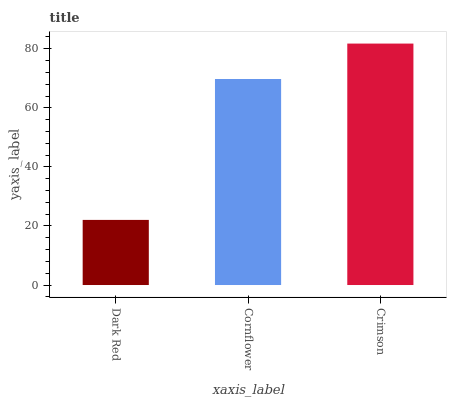Is Dark Red the minimum?
Answer yes or no. Yes. Is Crimson the maximum?
Answer yes or no. Yes. Is Cornflower the minimum?
Answer yes or no. No. Is Cornflower the maximum?
Answer yes or no. No. Is Cornflower greater than Dark Red?
Answer yes or no. Yes. Is Dark Red less than Cornflower?
Answer yes or no. Yes. Is Dark Red greater than Cornflower?
Answer yes or no. No. Is Cornflower less than Dark Red?
Answer yes or no. No. Is Cornflower the high median?
Answer yes or no. Yes. Is Cornflower the low median?
Answer yes or no. Yes. Is Dark Red the high median?
Answer yes or no. No. Is Dark Red the low median?
Answer yes or no. No. 